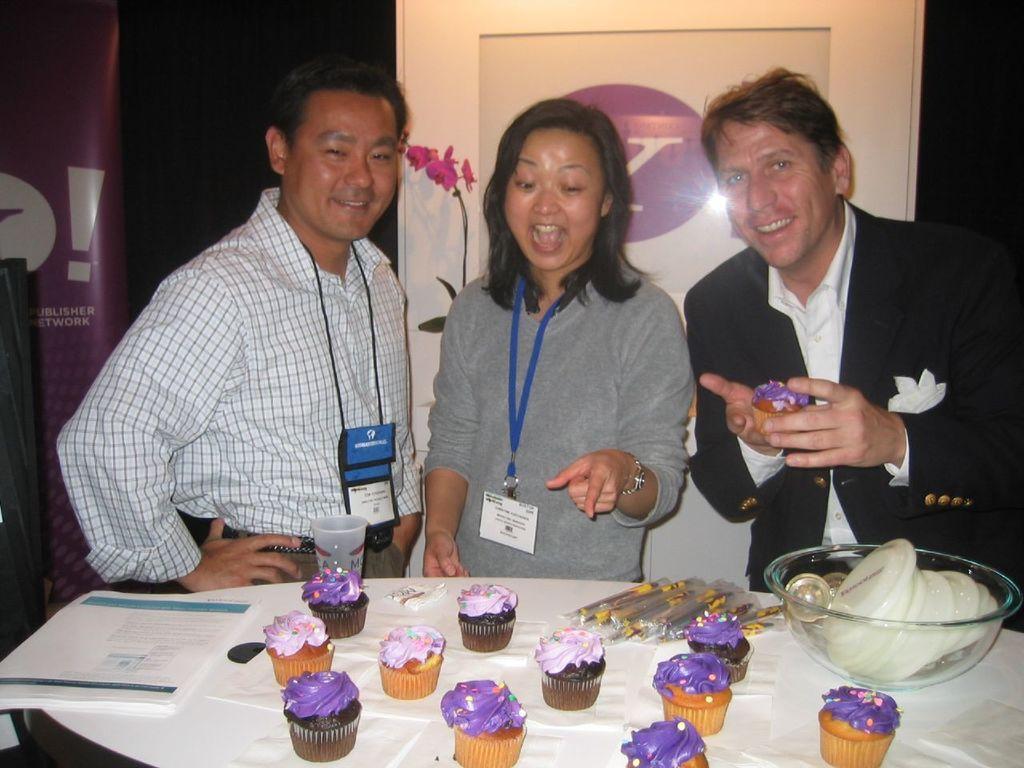Please provide a concise description of this image. There are two men and one woman standing and smiling. This is the table. I can see a glass bowl with plates, cupcakes, papers and few other objects on it. This looks like a board. At the left side of the image, that looks like a banner. 